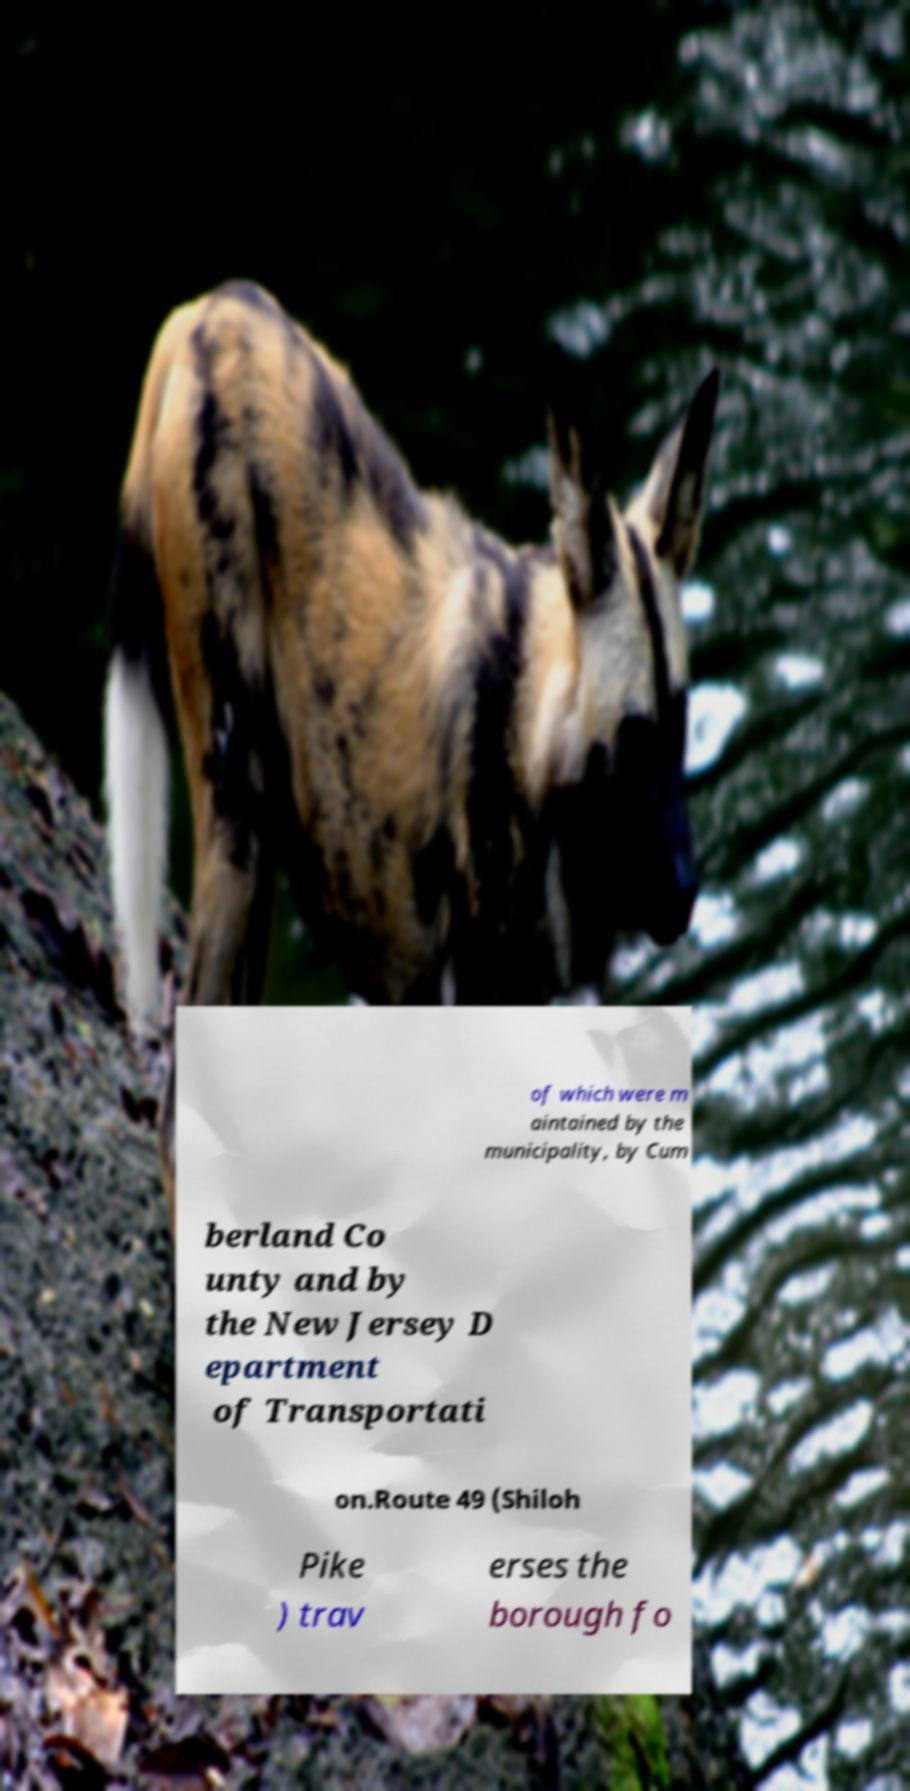Can you read and provide the text displayed in the image?This photo seems to have some interesting text. Can you extract and type it out for me? of which were m aintained by the municipality, by Cum berland Co unty and by the New Jersey D epartment of Transportati on.Route 49 (Shiloh Pike ) trav erses the borough fo 